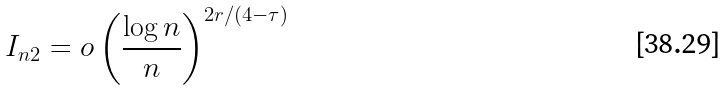Convert formula to latex. <formula><loc_0><loc_0><loc_500><loc_500>I _ { n 2 } = o \left ( \frac { \log n } n \right ) ^ { 2 r / ( 4 - \tau ) }</formula> 